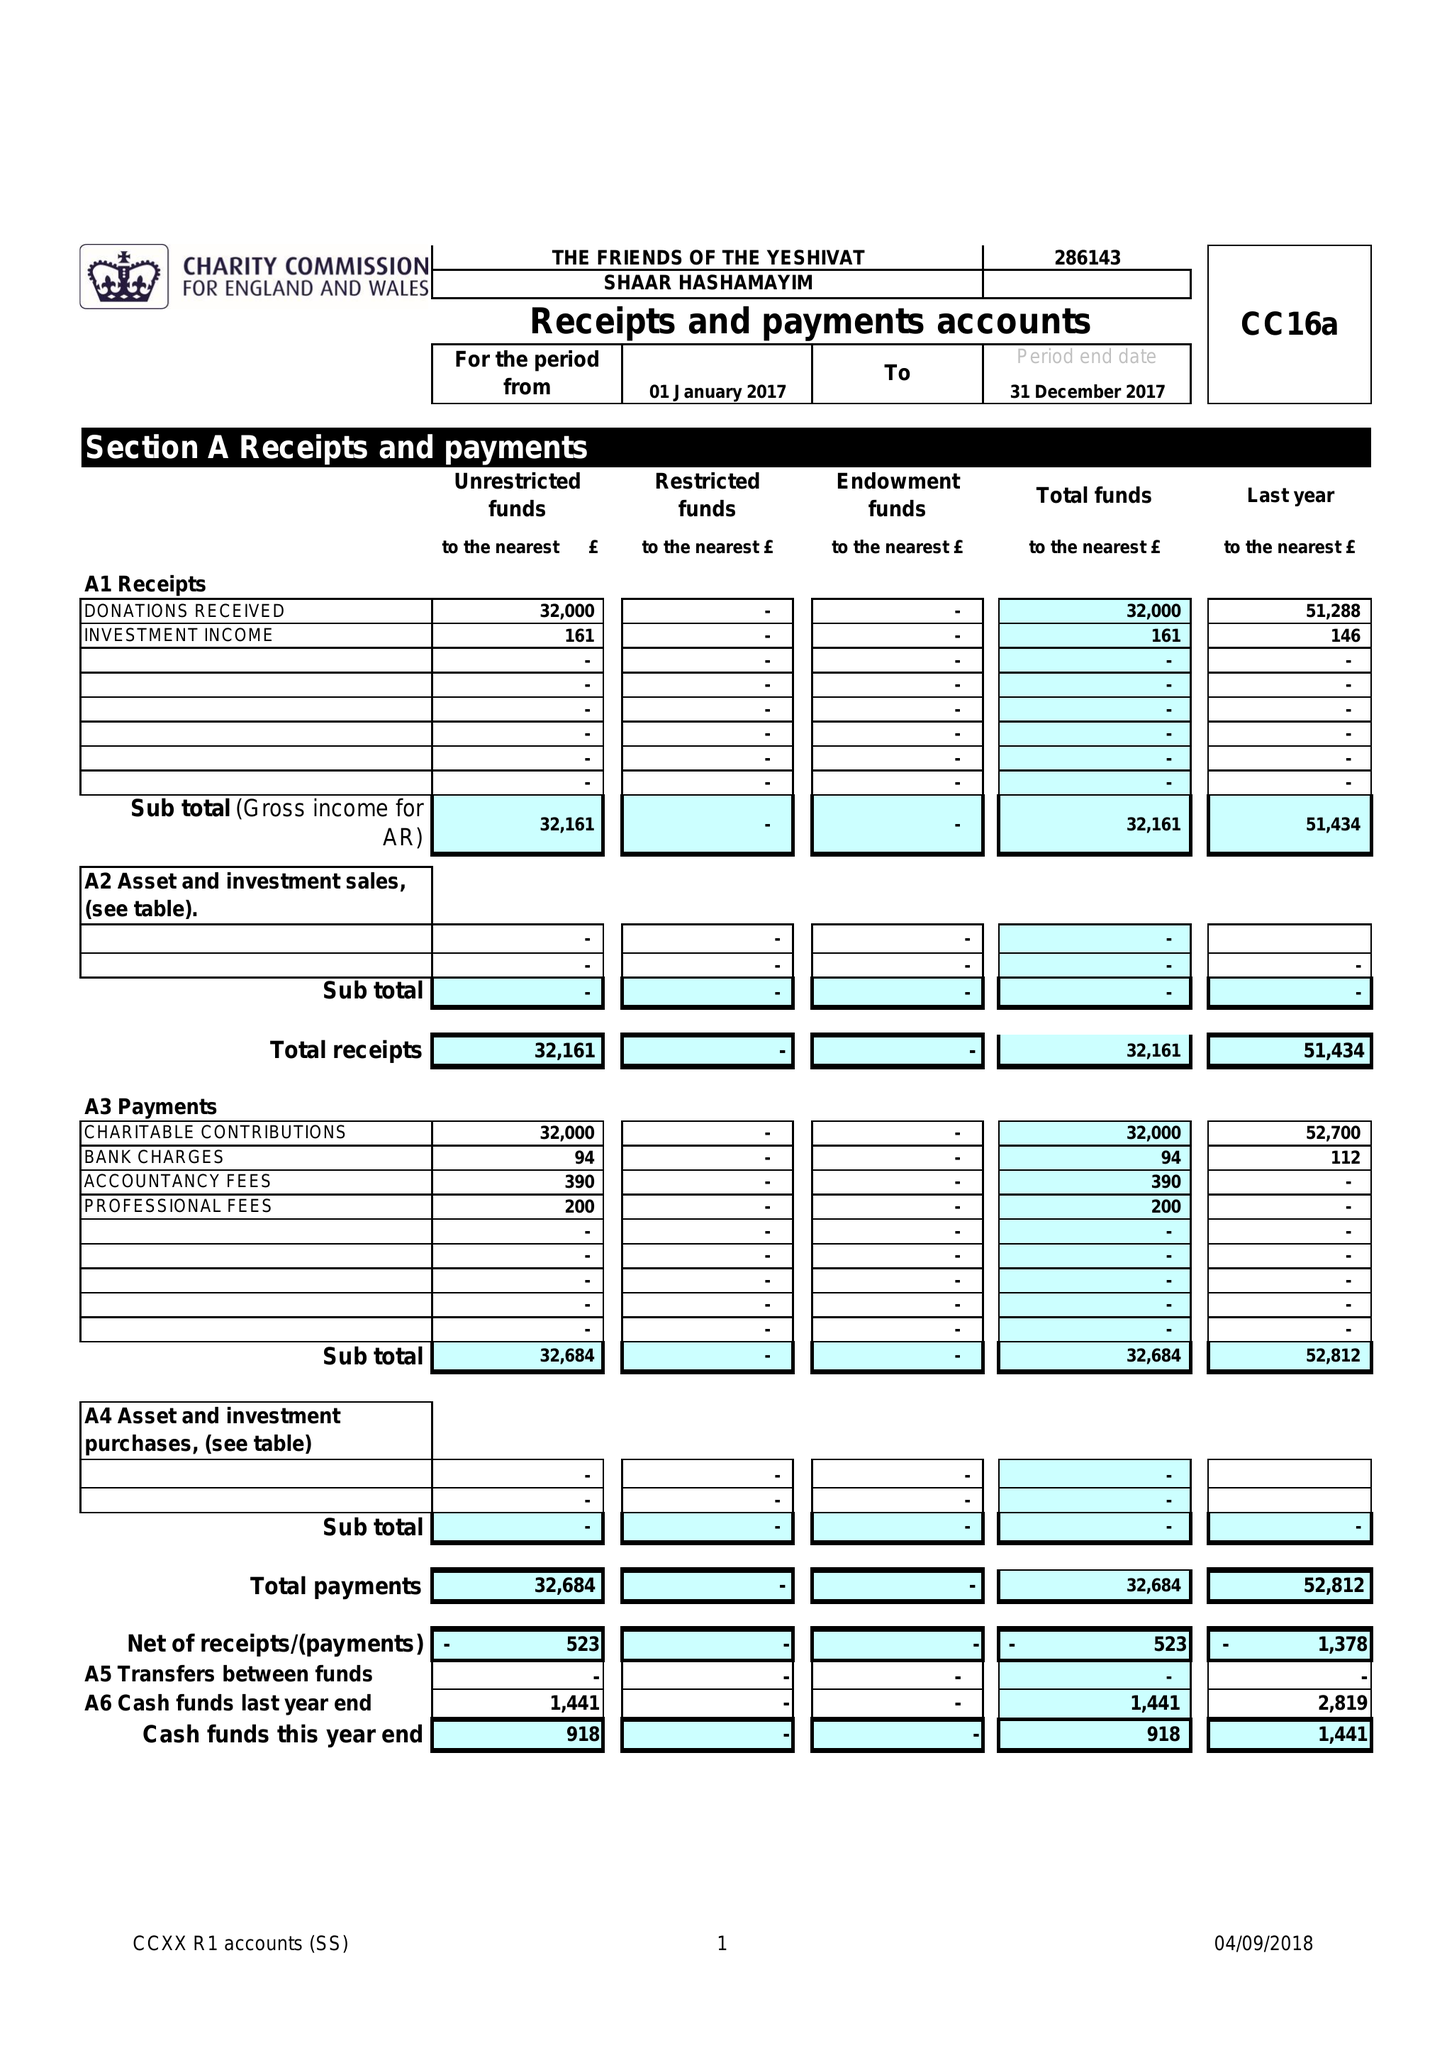What is the value for the charity_number?
Answer the question using a single word or phrase. 286143 